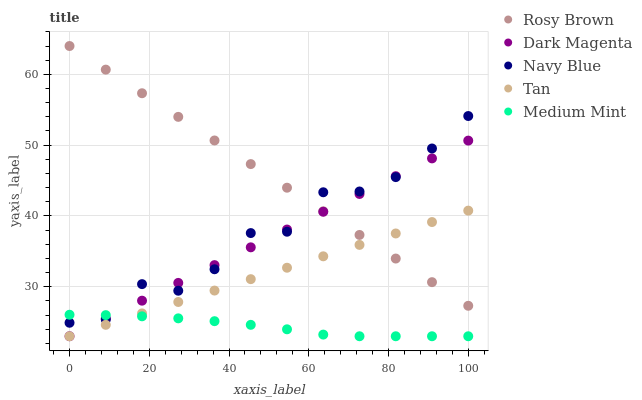Does Medium Mint have the minimum area under the curve?
Answer yes or no. Yes. Does Rosy Brown have the maximum area under the curve?
Answer yes or no. Yes. Does Navy Blue have the minimum area under the curve?
Answer yes or no. No. Does Navy Blue have the maximum area under the curve?
Answer yes or no. No. Is Tan the smoothest?
Answer yes or no. Yes. Is Navy Blue the roughest?
Answer yes or no. Yes. Is Navy Blue the smoothest?
Answer yes or no. No. Is Tan the roughest?
Answer yes or no. No. Does Medium Mint have the lowest value?
Answer yes or no. Yes. Does Navy Blue have the lowest value?
Answer yes or no. No. Does Rosy Brown have the highest value?
Answer yes or no. Yes. Does Navy Blue have the highest value?
Answer yes or no. No. Is Medium Mint less than Rosy Brown?
Answer yes or no. Yes. Is Navy Blue greater than Tan?
Answer yes or no. Yes. Does Dark Magenta intersect Tan?
Answer yes or no. Yes. Is Dark Magenta less than Tan?
Answer yes or no. No. Is Dark Magenta greater than Tan?
Answer yes or no. No. Does Medium Mint intersect Rosy Brown?
Answer yes or no. No. 